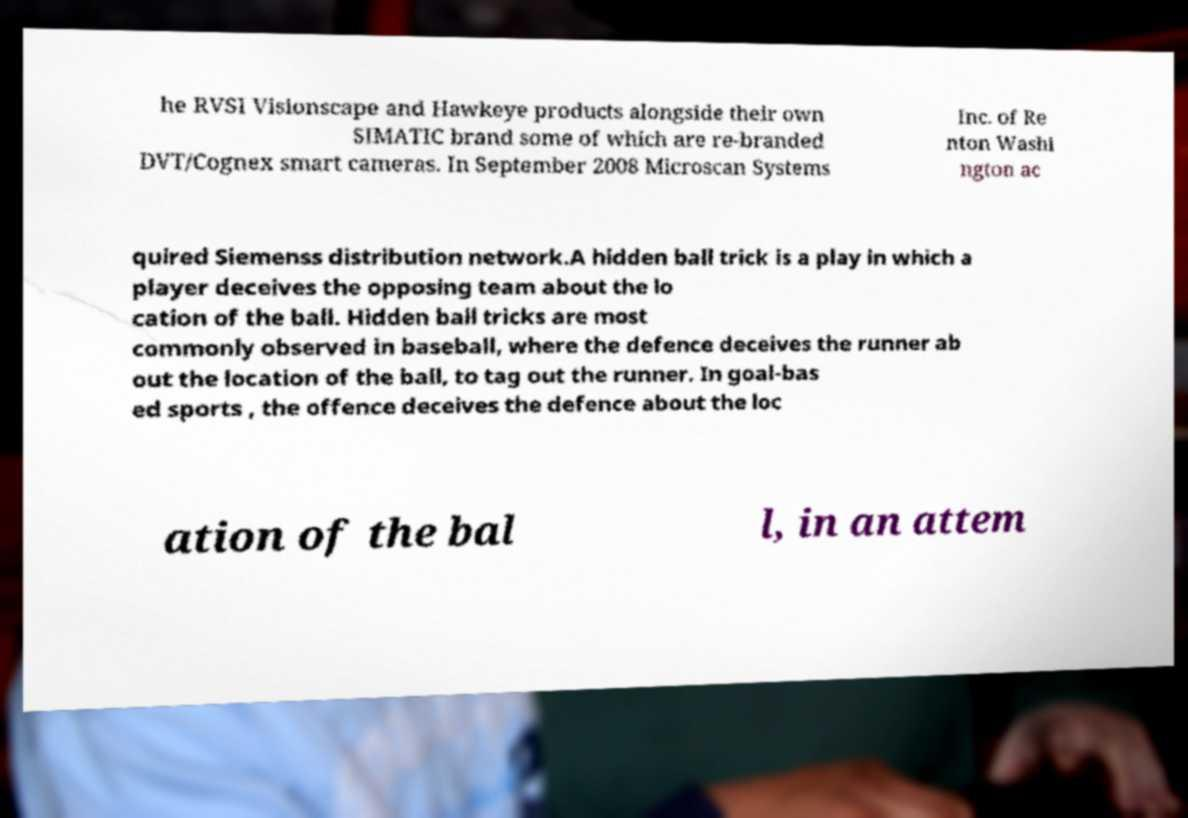Can you read and provide the text displayed in the image?This photo seems to have some interesting text. Can you extract and type it out for me? he RVSI Visionscape and Hawkeye products alongside their own SIMATIC brand some of which are re-branded DVT/Cognex smart cameras. In September 2008 Microscan Systems Inc. of Re nton Washi ngton ac quired Siemenss distribution network.A hidden ball trick is a play in which a player deceives the opposing team about the lo cation of the ball. Hidden ball tricks are most commonly observed in baseball, where the defence deceives the runner ab out the location of the ball, to tag out the runner. In goal-bas ed sports , the offence deceives the defence about the loc ation of the bal l, in an attem 